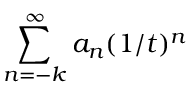<formula> <loc_0><loc_0><loc_500><loc_500>\sum _ { n = - k } ^ { \infty } a _ { n } ( 1 / t ) ^ { n }</formula> 